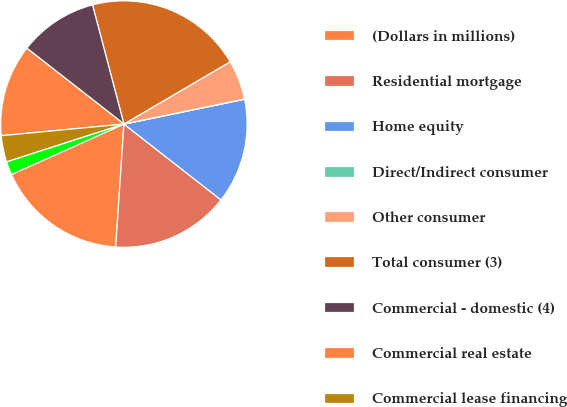Convert chart. <chart><loc_0><loc_0><loc_500><loc_500><pie_chart><fcel>(Dollars in millions)<fcel>Residential mortgage<fcel>Home equity<fcel>Direct/Indirect consumer<fcel>Other consumer<fcel>Total consumer (3)<fcel>Commercial - domestic (4)<fcel>Commercial real estate<fcel>Commercial lease financing<fcel>Commercial - foreign<nl><fcel>17.22%<fcel>15.5%<fcel>13.78%<fcel>0.02%<fcel>5.18%<fcel>20.66%<fcel>10.34%<fcel>12.06%<fcel>3.46%<fcel>1.74%<nl></chart> 